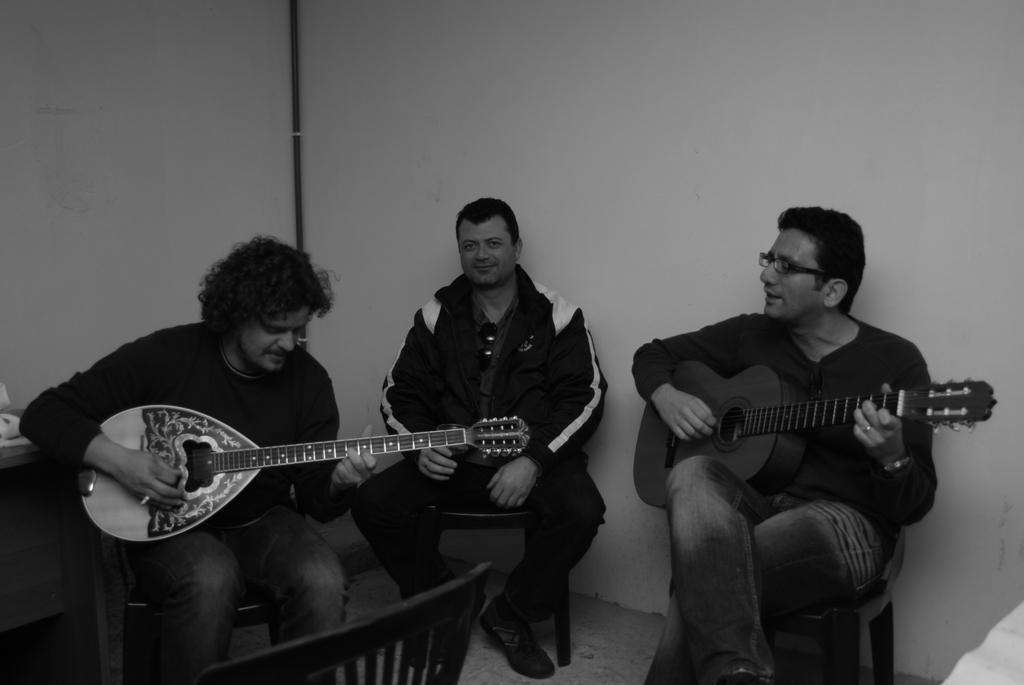Can you describe this image briefly? This picture is taken in a room, There are some people sitting on the chairs and they are holding some music instruments and in the background there is a white color wall. 